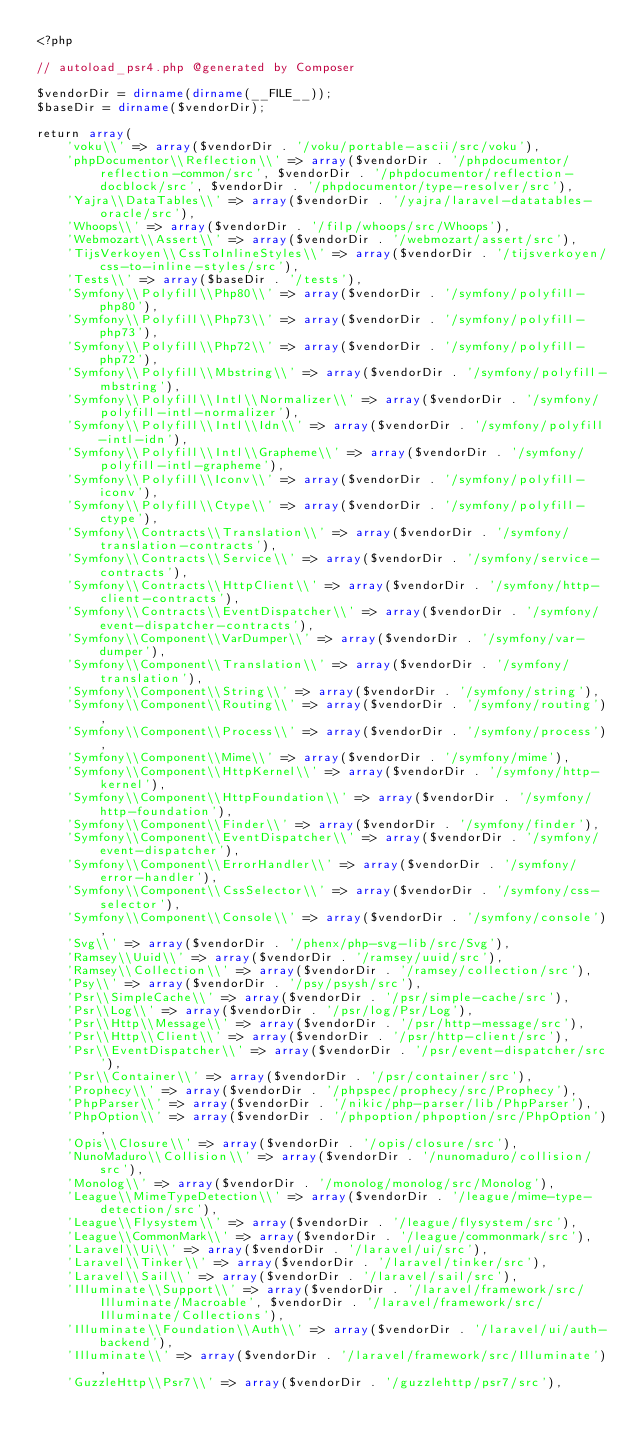Convert code to text. <code><loc_0><loc_0><loc_500><loc_500><_PHP_><?php

// autoload_psr4.php @generated by Composer

$vendorDir = dirname(dirname(__FILE__));
$baseDir = dirname($vendorDir);

return array(
    'voku\\' => array($vendorDir . '/voku/portable-ascii/src/voku'),
    'phpDocumentor\\Reflection\\' => array($vendorDir . '/phpdocumentor/reflection-common/src', $vendorDir . '/phpdocumentor/reflection-docblock/src', $vendorDir . '/phpdocumentor/type-resolver/src'),
    'Yajra\\DataTables\\' => array($vendorDir . '/yajra/laravel-datatables-oracle/src'),
    'Whoops\\' => array($vendorDir . '/filp/whoops/src/Whoops'),
    'Webmozart\\Assert\\' => array($vendorDir . '/webmozart/assert/src'),
    'TijsVerkoyen\\CssToInlineStyles\\' => array($vendorDir . '/tijsverkoyen/css-to-inline-styles/src'),
    'Tests\\' => array($baseDir . '/tests'),
    'Symfony\\Polyfill\\Php80\\' => array($vendorDir . '/symfony/polyfill-php80'),
    'Symfony\\Polyfill\\Php73\\' => array($vendorDir . '/symfony/polyfill-php73'),
    'Symfony\\Polyfill\\Php72\\' => array($vendorDir . '/symfony/polyfill-php72'),
    'Symfony\\Polyfill\\Mbstring\\' => array($vendorDir . '/symfony/polyfill-mbstring'),
    'Symfony\\Polyfill\\Intl\\Normalizer\\' => array($vendorDir . '/symfony/polyfill-intl-normalizer'),
    'Symfony\\Polyfill\\Intl\\Idn\\' => array($vendorDir . '/symfony/polyfill-intl-idn'),
    'Symfony\\Polyfill\\Intl\\Grapheme\\' => array($vendorDir . '/symfony/polyfill-intl-grapheme'),
    'Symfony\\Polyfill\\Iconv\\' => array($vendorDir . '/symfony/polyfill-iconv'),
    'Symfony\\Polyfill\\Ctype\\' => array($vendorDir . '/symfony/polyfill-ctype'),
    'Symfony\\Contracts\\Translation\\' => array($vendorDir . '/symfony/translation-contracts'),
    'Symfony\\Contracts\\Service\\' => array($vendorDir . '/symfony/service-contracts'),
    'Symfony\\Contracts\\HttpClient\\' => array($vendorDir . '/symfony/http-client-contracts'),
    'Symfony\\Contracts\\EventDispatcher\\' => array($vendorDir . '/symfony/event-dispatcher-contracts'),
    'Symfony\\Component\\VarDumper\\' => array($vendorDir . '/symfony/var-dumper'),
    'Symfony\\Component\\Translation\\' => array($vendorDir . '/symfony/translation'),
    'Symfony\\Component\\String\\' => array($vendorDir . '/symfony/string'),
    'Symfony\\Component\\Routing\\' => array($vendorDir . '/symfony/routing'),
    'Symfony\\Component\\Process\\' => array($vendorDir . '/symfony/process'),
    'Symfony\\Component\\Mime\\' => array($vendorDir . '/symfony/mime'),
    'Symfony\\Component\\HttpKernel\\' => array($vendorDir . '/symfony/http-kernel'),
    'Symfony\\Component\\HttpFoundation\\' => array($vendorDir . '/symfony/http-foundation'),
    'Symfony\\Component\\Finder\\' => array($vendorDir . '/symfony/finder'),
    'Symfony\\Component\\EventDispatcher\\' => array($vendorDir . '/symfony/event-dispatcher'),
    'Symfony\\Component\\ErrorHandler\\' => array($vendorDir . '/symfony/error-handler'),
    'Symfony\\Component\\CssSelector\\' => array($vendorDir . '/symfony/css-selector'),
    'Symfony\\Component\\Console\\' => array($vendorDir . '/symfony/console'),
    'Svg\\' => array($vendorDir . '/phenx/php-svg-lib/src/Svg'),
    'Ramsey\\Uuid\\' => array($vendorDir . '/ramsey/uuid/src'),
    'Ramsey\\Collection\\' => array($vendorDir . '/ramsey/collection/src'),
    'Psy\\' => array($vendorDir . '/psy/psysh/src'),
    'Psr\\SimpleCache\\' => array($vendorDir . '/psr/simple-cache/src'),
    'Psr\\Log\\' => array($vendorDir . '/psr/log/Psr/Log'),
    'Psr\\Http\\Message\\' => array($vendorDir . '/psr/http-message/src'),
    'Psr\\Http\\Client\\' => array($vendorDir . '/psr/http-client/src'),
    'Psr\\EventDispatcher\\' => array($vendorDir . '/psr/event-dispatcher/src'),
    'Psr\\Container\\' => array($vendorDir . '/psr/container/src'),
    'Prophecy\\' => array($vendorDir . '/phpspec/prophecy/src/Prophecy'),
    'PhpParser\\' => array($vendorDir . '/nikic/php-parser/lib/PhpParser'),
    'PhpOption\\' => array($vendorDir . '/phpoption/phpoption/src/PhpOption'),
    'Opis\\Closure\\' => array($vendorDir . '/opis/closure/src'),
    'NunoMaduro\\Collision\\' => array($vendorDir . '/nunomaduro/collision/src'),
    'Monolog\\' => array($vendorDir . '/monolog/monolog/src/Monolog'),
    'League\\MimeTypeDetection\\' => array($vendorDir . '/league/mime-type-detection/src'),
    'League\\Flysystem\\' => array($vendorDir . '/league/flysystem/src'),
    'League\\CommonMark\\' => array($vendorDir . '/league/commonmark/src'),
    'Laravel\\Ui\\' => array($vendorDir . '/laravel/ui/src'),
    'Laravel\\Tinker\\' => array($vendorDir . '/laravel/tinker/src'),
    'Laravel\\Sail\\' => array($vendorDir . '/laravel/sail/src'),
    'Illuminate\\Support\\' => array($vendorDir . '/laravel/framework/src/Illuminate/Macroable', $vendorDir . '/laravel/framework/src/Illuminate/Collections'),
    'Illuminate\\Foundation\\Auth\\' => array($vendorDir . '/laravel/ui/auth-backend'),
    'Illuminate\\' => array($vendorDir . '/laravel/framework/src/Illuminate'),
    'GuzzleHttp\\Psr7\\' => array($vendorDir . '/guzzlehttp/psr7/src'),</code> 